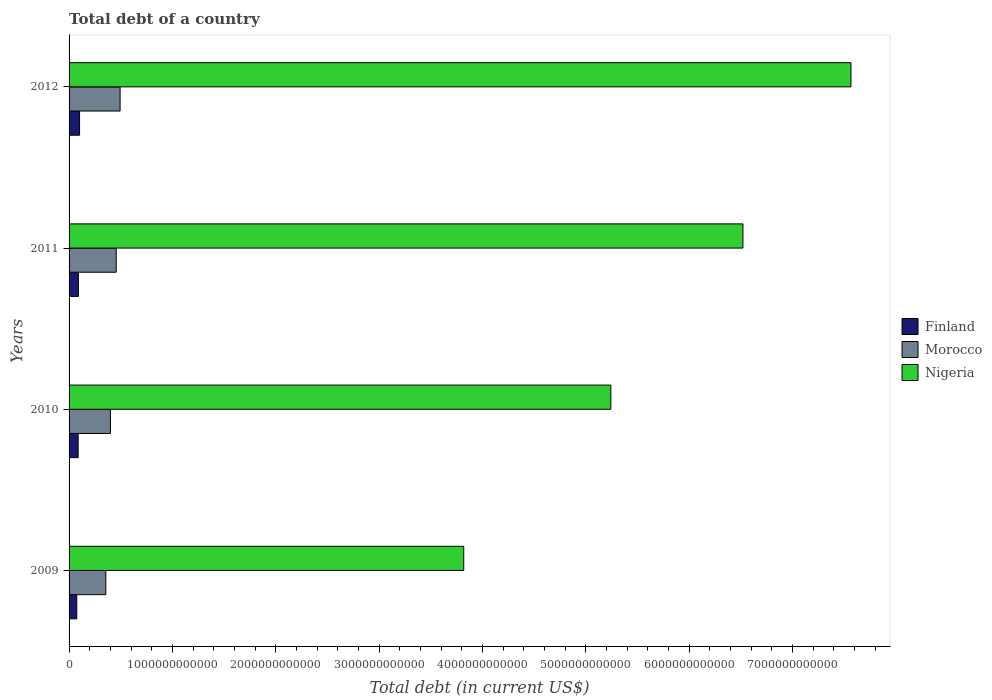How many different coloured bars are there?
Provide a succinct answer. 3. Are the number of bars per tick equal to the number of legend labels?
Offer a terse response. Yes. Are the number of bars on each tick of the Y-axis equal?
Provide a short and direct response. Yes. How many bars are there on the 2nd tick from the top?
Provide a succinct answer. 3. In how many cases, is the number of bars for a given year not equal to the number of legend labels?
Provide a succinct answer. 0. What is the debt in Finland in 2012?
Give a very brief answer. 1.02e+11. Across all years, what is the maximum debt in Finland?
Your answer should be compact. 1.02e+11. Across all years, what is the minimum debt in Morocco?
Provide a short and direct response. 3.56e+11. In which year was the debt in Morocco maximum?
Your answer should be compact. 2012. What is the total debt in Nigeria in the graph?
Your answer should be compact. 2.31e+13. What is the difference between the debt in Finland in 2009 and that in 2012?
Make the answer very short. -2.69e+1. What is the difference between the debt in Finland in 2009 and the debt in Nigeria in 2012?
Provide a succinct answer. -7.49e+12. What is the average debt in Nigeria per year?
Keep it short and to the point. 5.79e+12. In the year 2009, what is the difference between the debt in Morocco and debt in Nigeria?
Make the answer very short. -3.46e+12. In how many years, is the debt in Morocco greater than 2800000000000 US$?
Keep it short and to the point. 0. What is the ratio of the debt in Morocco in 2009 to that in 2011?
Keep it short and to the point. 0.78. What is the difference between the highest and the second highest debt in Morocco?
Give a very brief answer. 3.75e+1. What is the difference between the highest and the lowest debt in Morocco?
Ensure brevity in your answer.  1.38e+11. In how many years, is the debt in Morocco greater than the average debt in Morocco taken over all years?
Your response must be concise. 2. Is the sum of the debt in Nigeria in 2011 and 2012 greater than the maximum debt in Finland across all years?
Keep it short and to the point. Yes. What does the 3rd bar from the top in 2012 represents?
Offer a terse response. Finland. What does the 2nd bar from the bottom in 2009 represents?
Offer a very short reply. Morocco. How many years are there in the graph?
Provide a succinct answer. 4. What is the difference between two consecutive major ticks on the X-axis?
Your answer should be very brief. 1.00e+12. Does the graph contain grids?
Provide a short and direct response. No. How many legend labels are there?
Offer a terse response. 3. How are the legend labels stacked?
Ensure brevity in your answer.  Vertical. What is the title of the graph?
Ensure brevity in your answer.  Total debt of a country. What is the label or title of the X-axis?
Your answer should be compact. Total debt (in current US$). What is the Total debt (in current US$) in Finland in 2009?
Give a very brief answer. 7.47e+1. What is the Total debt (in current US$) of Morocco in 2009?
Your answer should be compact. 3.56e+11. What is the Total debt (in current US$) in Nigeria in 2009?
Offer a terse response. 3.82e+12. What is the Total debt (in current US$) in Finland in 2010?
Your answer should be very brief. 8.79e+1. What is the Total debt (in current US$) in Morocco in 2010?
Keep it short and to the point. 4.00e+11. What is the Total debt (in current US$) in Nigeria in 2010?
Your response must be concise. 5.24e+12. What is the Total debt (in current US$) in Finland in 2011?
Keep it short and to the point. 9.05e+1. What is the Total debt (in current US$) in Morocco in 2011?
Offer a very short reply. 4.56e+11. What is the Total debt (in current US$) of Nigeria in 2011?
Ensure brevity in your answer.  6.52e+12. What is the Total debt (in current US$) of Finland in 2012?
Your answer should be very brief. 1.02e+11. What is the Total debt (in current US$) in Morocco in 2012?
Offer a terse response. 4.94e+11. What is the Total debt (in current US$) in Nigeria in 2012?
Provide a short and direct response. 7.56e+12. Across all years, what is the maximum Total debt (in current US$) in Finland?
Your answer should be compact. 1.02e+11. Across all years, what is the maximum Total debt (in current US$) in Morocco?
Give a very brief answer. 4.94e+11. Across all years, what is the maximum Total debt (in current US$) of Nigeria?
Your response must be concise. 7.56e+12. Across all years, what is the minimum Total debt (in current US$) in Finland?
Provide a succinct answer. 7.47e+1. Across all years, what is the minimum Total debt (in current US$) of Morocco?
Offer a very short reply. 3.56e+11. Across all years, what is the minimum Total debt (in current US$) in Nigeria?
Your answer should be very brief. 3.82e+12. What is the total Total debt (in current US$) of Finland in the graph?
Your response must be concise. 3.55e+11. What is the total Total debt (in current US$) in Morocco in the graph?
Make the answer very short. 1.71e+12. What is the total Total debt (in current US$) of Nigeria in the graph?
Your response must be concise. 2.31e+13. What is the difference between the Total debt (in current US$) in Finland in 2009 and that in 2010?
Your answer should be very brief. -1.33e+1. What is the difference between the Total debt (in current US$) of Morocco in 2009 and that in 2010?
Your answer should be very brief. -4.43e+1. What is the difference between the Total debt (in current US$) in Nigeria in 2009 and that in 2010?
Ensure brevity in your answer.  -1.42e+12. What is the difference between the Total debt (in current US$) in Finland in 2009 and that in 2011?
Ensure brevity in your answer.  -1.58e+1. What is the difference between the Total debt (in current US$) in Morocco in 2009 and that in 2011?
Offer a very short reply. -1.01e+11. What is the difference between the Total debt (in current US$) in Nigeria in 2009 and that in 2011?
Your answer should be very brief. -2.70e+12. What is the difference between the Total debt (in current US$) in Finland in 2009 and that in 2012?
Make the answer very short. -2.69e+1. What is the difference between the Total debt (in current US$) of Morocco in 2009 and that in 2012?
Your response must be concise. -1.38e+11. What is the difference between the Total debt (in current US$) of Nigeria in 2009 and that in 2012?
Your response must be concise. -3.75e+12. What is the difference between the Total debt (in current US$) of Finland in 2010 and that in 2011?
Offer a terse response. -2.55e+09. What is the difference between the Total debt (in current US$) of Morocco in 2010 and that in 2011?
Keep it short and to the point. -5.63e+1. What is the difference between the Total debt (in current US$) of Nigeria in 2010 and that in 2011?
Keep it short and to the point. -1.28e+12. What is the difference between the Total debt (in current US$) of Finland in 2010 and that in 2012?
Your answer should be very brief. -1.36e+1. What is the difference between the Total debt (in current US$) in Morocco in 2010 and that in 2012?
Make the answer very short. -9.38e+1. What is the difference between the Total debt (in current US$) in Nigeria in 2010 and that in 2012?
Your answer should be very brief. -2.32e+12. What is the difference between the Total debt (in current US$) in Finland in 2011 and that in 2012?
Your response must be concise. -1.11e+1. What is the difference between the Total debt (in current US$) in Morocco in 2011 and that in 2012?
Your answer should be compact. -3.75e+1. What is the difference between the Total debt (in current US$) in Nigeria in 2011 and that in 2012?
Make the answer very short. -1.04e+12. What is the difference between the Total debt (in current US$) in Finland in 2009 and the Total debt (in current US$) in Morocco in 2010?
Keep it short and to the point. -3.25e+11. What is the difference between the Total debt (in current US$) in Finland in 2009 and the Total debt (in current US$) in Nigeria in 2010?
Your answer should be very brief. -5.17e+12. What is the difference between the Total debt (in current US$) of Morocco in 2009 and the Total debt (in current US$) of Nigeria in 2010?
Provide a short and direct response. -4.89e+12. What is the difference between the Total debt (in current US$) in Finland in 2009 and the Total debt (in current US$) in Morocco in 2011?
Provide a succinct answer. -3.82e+11. What is the difference between the Total debt (in current US$) of Finland in 2009 and the Total debt (in current US$) of Nigeria in 2011?
Offer a terse response. -6.44e+12. What is the difference between the Total debt (in current US$) in Morocco in 2009 and the Total debt (in current US$) in Nigeria in 2011?
Your answer should be very brief. -6.16e+12. What is the difference between the Total debt (in current US$) in Finland in 2009 and the Total debt (in current US$) in Morocco in 2012?
Offer a terse response. -4.19e+11. What is the difference between the Total debt (in current US$) in Finland in 2009 and the Total debt (in current US$) in Nigeria in 2012?
Ensure brevity in your answer.  -7.49e+12. What is the difference between the Total debt (in current US$) of Morocco in 2009 and the Total debt (in current US$) of Nigeria in 2012?
Offer a terse response. -7.21e+12. What is the difference between the Total debt (in current US$) in Finland in 2010 and the Total debt (in current US$) in Morocco in 2011?
Provide a short and direct response. -3.68e+11. What is the difference between the Total debt (in current US$) of Finland in 2010 and the Total debt (in current US$) of Nigeria in 2011?
Offer a terse response. -6.43e+12. What is the difference between the Total debt (in current US$) of Morocco in 2010 and the Total debt (in current US$) of Nigeria in 2011?
Offer a terse response. -6.12e+12. What is the difference between the Total debt (in current US$) in Finland in 2010 and the Total debt (in current US$) in Morocco in 2012?
Ensure brevity in your answer.  -4.06e+11. What is the difference between the Total debt (in current US$) of Finland in 2010 and the Total debt (in current US$) of Nigeria in 2012?
Your answer should be very brief. -7.48e+12. What is the difference between the Total debt (in current US$) of Morocco in 2010 and the Total debt (in current US$) of Nigeria in 2012?
Make the answer very short. -7.16e+12. What is the difference between the Total debt (in current US$) in Finland in 2011 and the Total debt (in current US$) in Morocco in 2012?
Ensure brevity in your answer.  -4.03e+11. What is the difference between the Total debt (in current US$) of Finland in 2011 and the Total debt (in current US$) of Nigeria in 2012?
Your answer should be compact. -7.47e+12. What is the difference between the Total debt (in current US$) of Morocco in 2011 and the Total debt (in current US$) of Nigeria in 2012?
Provide a short and direct response. -7.11e+12. What is the average Total debt (in current US$) in Finland per year?
Your response must be concise. 8.86e+1. What is the average Total debt (in current US$) of Morocco per year?
Ensure brevity in your answer.  4.26e+11. What is the average Total debt (in current US$) in Nigeria per year?
Ensure brevity in your answer.  5.79e+12. In the year 2009, what is the difference between the Total debt (in current US$) in Finland and Total debt (in current US$) in Morocco?
Give a very brief answer. -2.81e+11. In the year 2009, what is the difference between the Total debt (in current US$) in Finland and Total debt (in current US$) in Nigeria?
Make the answer very short. -3.74e+12. In the year 2009, what is the difference between the Total debt (in current US$) of Morocco and Total debt (in current US$) of Nigeria?
Your answer should be compact. -3.46e+12. In the year 2010, what is the difference between the Total debt (in current US$) in Finland and Total debt (in current US$) in Morocco?
Your answer should be compact. -3.12e+11. In the year 2010, what is the difference between the Total debt (in current US$) in Finland and Total debt (in current US$) in Nigeria?
Offer a terse response. -5.15e+12. In the year 2010, what is the difference between the Total debt (in current US$) in Morocco and Total debt (in current US$) in Nigeria?
Your answer should be compact. -4.84e+12. In the year 2011, what is the difference between the Total debt (in current US$) in Finland and Total debt (in current US$) in Morocco?
Offer a very short reply. -3.66e+11. In the year 2011, what is the difference between the Total debt (in current US$) in Finland and Total debt (in current US$) in Nigeria?
Your answer should be compact. -6.43e+12. In the year 2011, what is the difference between the Total debt (in current US$) in Morocco and Total debt (in current US$) in Nigeria?
Give a very brief answer. -6.06e+12. In the year 2012, what is the difference between the Total debt (in current US$) in Finland and Total debt (in current US$) in Morocco?
Your response must be concise. -3.92e+11. In the year 2012, what is the difference between the Total debt (in current US$) of Finland and Total debt (in current US$) of Nigeria?
Your answer should be compact. -7.46e+12. In the year 2012, what is the difference between the Total debt (in current US$) in Morocco and Total debt (in current US$) in Nigeria?
Ensure brevity in your answer.  -7.07e+12. What is the ratio of the Total debt (in current US$) of Finland in 2009 to that in 2010?
Provide a succinct answer. 0.85. What is the ratio of the Total debt (in current US$) of Morocco in 2009 to that in 2010?
Your answer should be compact. 0.89. What is the ratio of the Total debt (in current US$) in Nigeria in 2009 to that in 2010?
Your response must be concise. 0.73. What is the ratio of the Total debt (in current US$) of Finland in 2009 to that in 2011?
Offer a terse response. 0.83. What is the ratio of the Total debt (in current US$) of Morocco in 2009 to that in 2011?
Provide a succinct answer. 0.78. What is the ratio of the Total debt (in current US$) in Nigeria in 2009 to that in 2011?
Offer a terse response. 0.59. What is the ratio of the Total debt (in current US$) in Finland in 2009 to that in 2012?
Your response must be concise. 0.74. What is the ratio of the Total debt (in current US$) in Morocco in 2009 to that in 2012?
Your answer should be very brief. 0.72. What is the ratio of the Total debt (in current US$) of Nigeria in 2009 to that in 2012?
Your answer should be compact. 0.5. What is the ratio of the Total debt (in current US$) of Finland in 2010 to that in 2011?
Ensure brevity in your answer.  0.97. What is the ratio of the Total debt (in current US$) in Morocco in 2010 to that in 2011?
Your answer should be very brief. 0.88. What is the ratio of the Total debt (in current US$) in Nigeria in 2010 to that in 2011?
Ensure brevity in your answer.  0.8. What is the ratio of the Total debt (in current US$) of Finland in 2010 to that in 2012?
Keep it short and to the point. 0.87. What is the ratio of the Total debt (in current US$) in Morocco in 2010 to that in 2012?
Offer a very short reply. 0.81. What is the ratio of the Total debt (in current US$) of Nigeria in 2010 to that in 2012?
Make the answer very short. 0.69. What is the ratio of the Total debt (in current US$) in Finland in 2011 to that in 2012?
Make the answer very short. 0.89. What is the ratio of the Total debt (in current US$) of Morocco in 2011 to that in 2012?
Your answer should be compact. 0.92. What is the ratio of the Total debt (in current US$) in Nigeria in 2011 to that in 2012?
Offer a terse response. 0.86. What is the difference between the highest and the second highest Total debt (in current US$) of Finland?
Your answer should be compact. 1.11e+1. What is the difference between the highest and the second highest Total debt (in current US$) of Morocco?
Your answer should be very brief. 3.75e+1. What is the difference between the highest and the second highest Total debt (in current US$) of Nigeria?
Give a very brief answer. 1.04e+12. What is the difference between the highest and the lowest Total debt (in current US$) of Finland?
Keep it short and to the point. 2.69e+1. What is the difference between the highest and the lowest Total debt (in current US$) of Morocco?
Keep it short and to the point. 1.38e+11. What is the difference between the highest and the lowest Total debt (in current US$) of Nigeria?
Your response must be concise. 3.75e+12. 